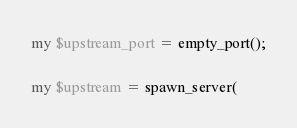Convert code to text. <code><loc_0><loc_0><loc_500><loc_500><_Perl_>
my $upstream_port = empty_port();

my $upstream = spawn_server(</code> 